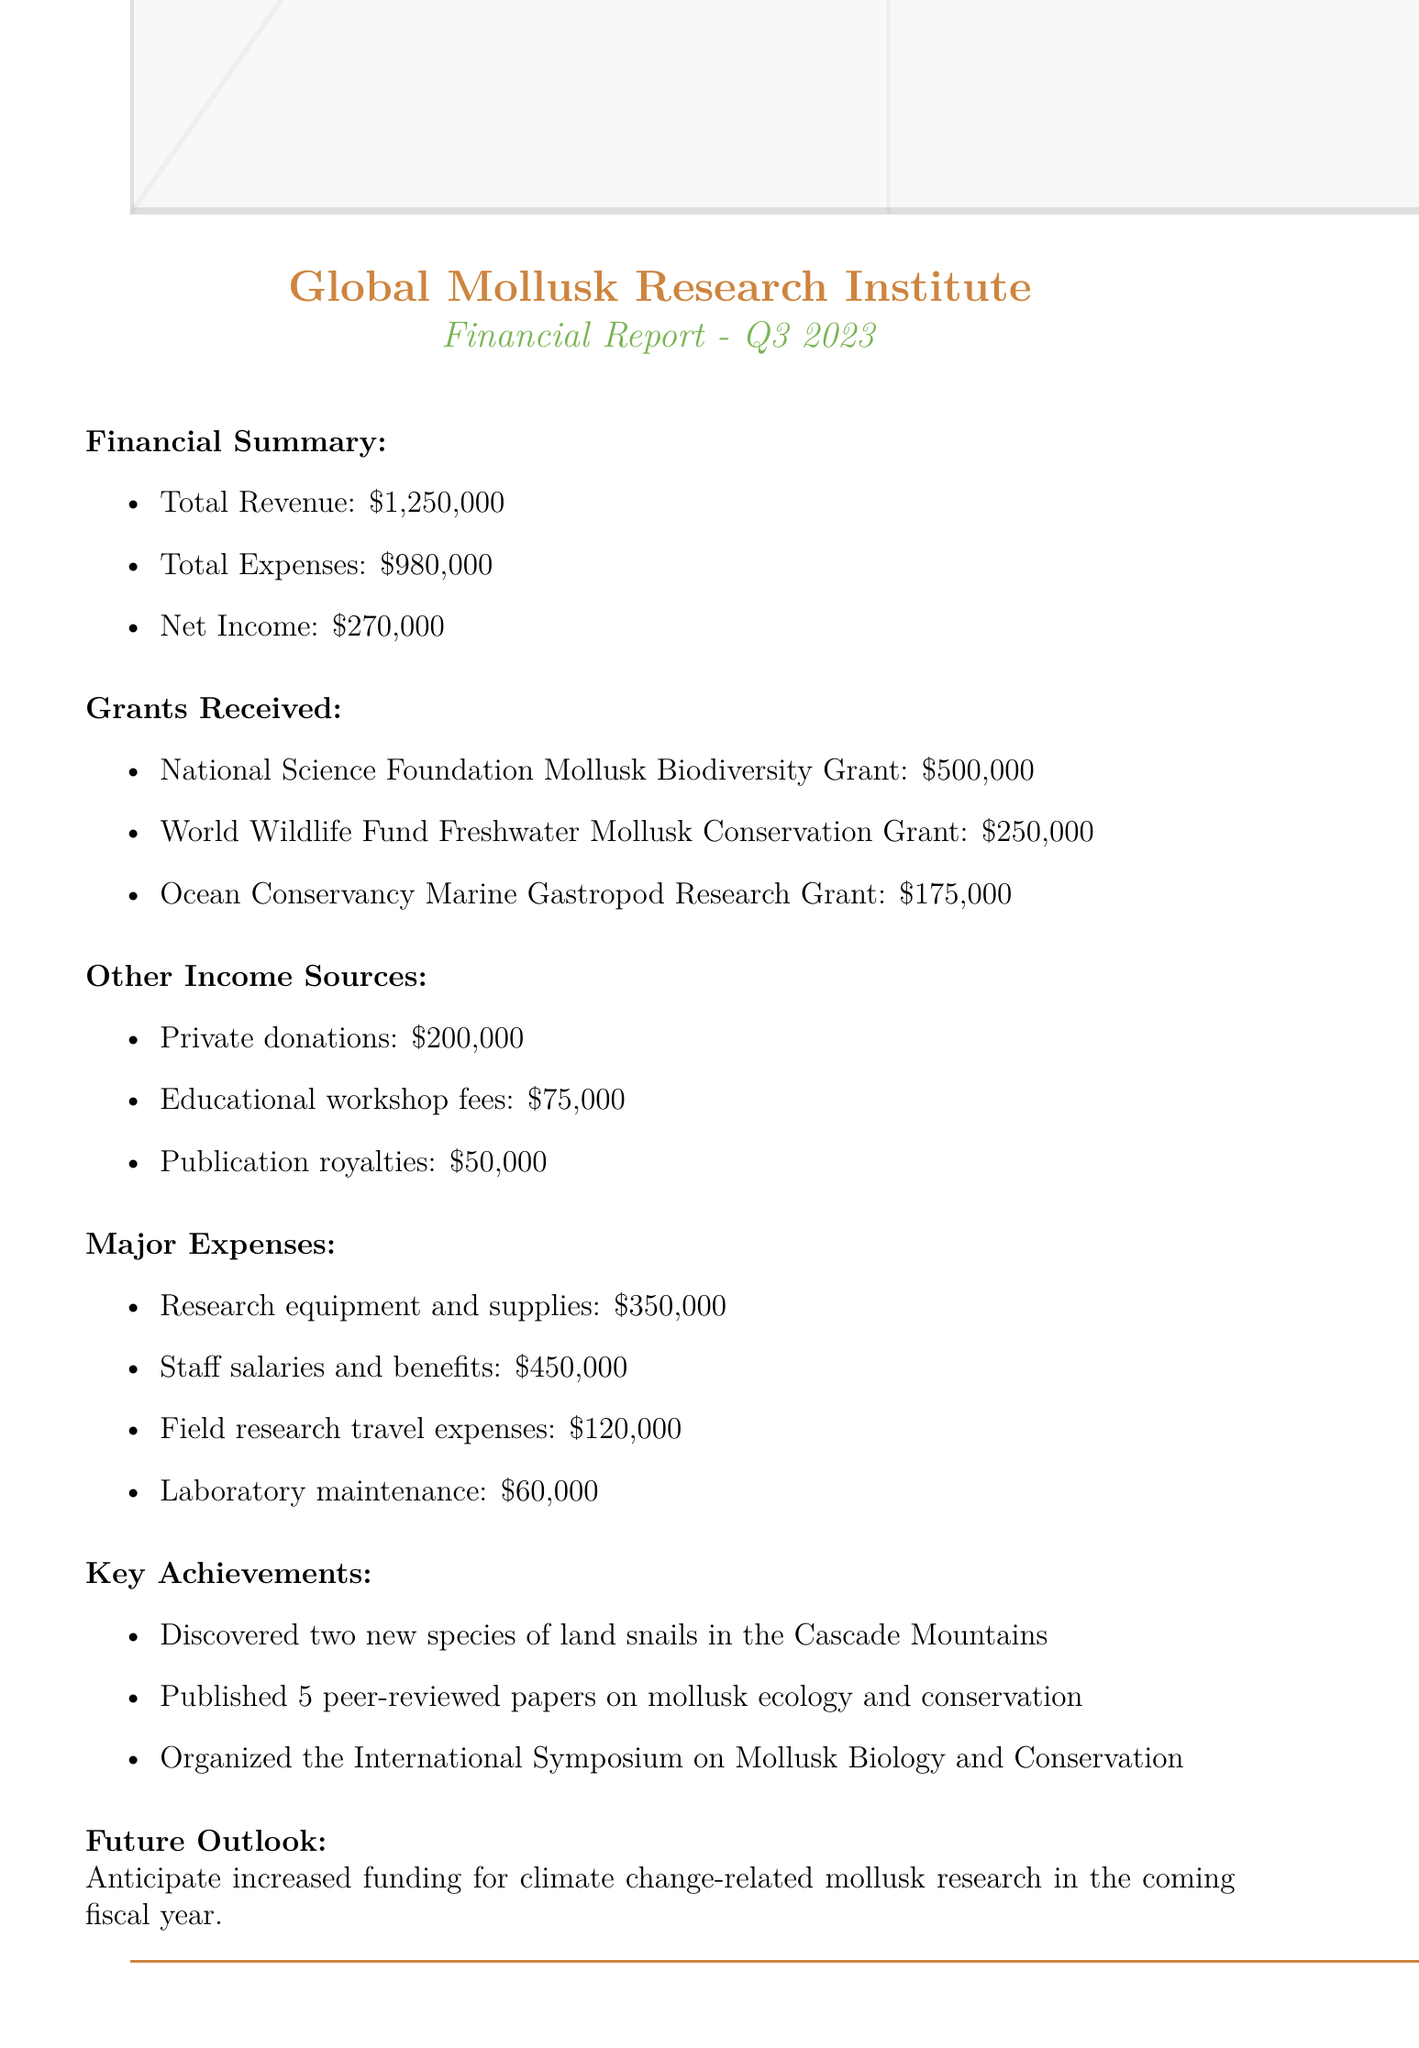what is the total revenue? The total revenue is provided in the financial summary section of the document, which states it as $1,250,000.
Answer: $1,250,000 how much was received from the National Science Foundation? The amount received from the National Science Foundation Mollusk Biodiversity Grant is specified in the grants received section, which is $500,000.
Answer: $500,000 what category had the highest expenses? The major expenses section lists several categories, with staff salaries and benefits being the highest at $450,000.
Answer: Staff salaries and benefits how many new species of land snails were discovered? The key achievements section mentions the discovery of two new species, which is explicitly stated.
Answer: two what is the purpose of the Ocean Conservancy Marine Gastropod Research Grant? The document describes the purpose of the grant, which is to investigate climate change impacts on marine snail shell development.
Answer: Investigation of climate change impacts on marine snail shell development what was the net income for Q3 2023? The net income is part of the financial summary and is provided as $270,000.
Answer: $270,000 what are the total expenses for the quarter? The document presents total expenses in the financial summary section, listed as $980,000.
Answer: $980,000 what future outlook is mentioned in the report? The future outlook section of the document talks about anticipating increased funding for climate change-related mollusk research.
Answer: Increased funding for climate change-related mollusk research how many peer-reviewed papers were published? According to the key achievements section, five peer-reviewed papers were published on mollusk ecology and conservation.
Answer: 5 